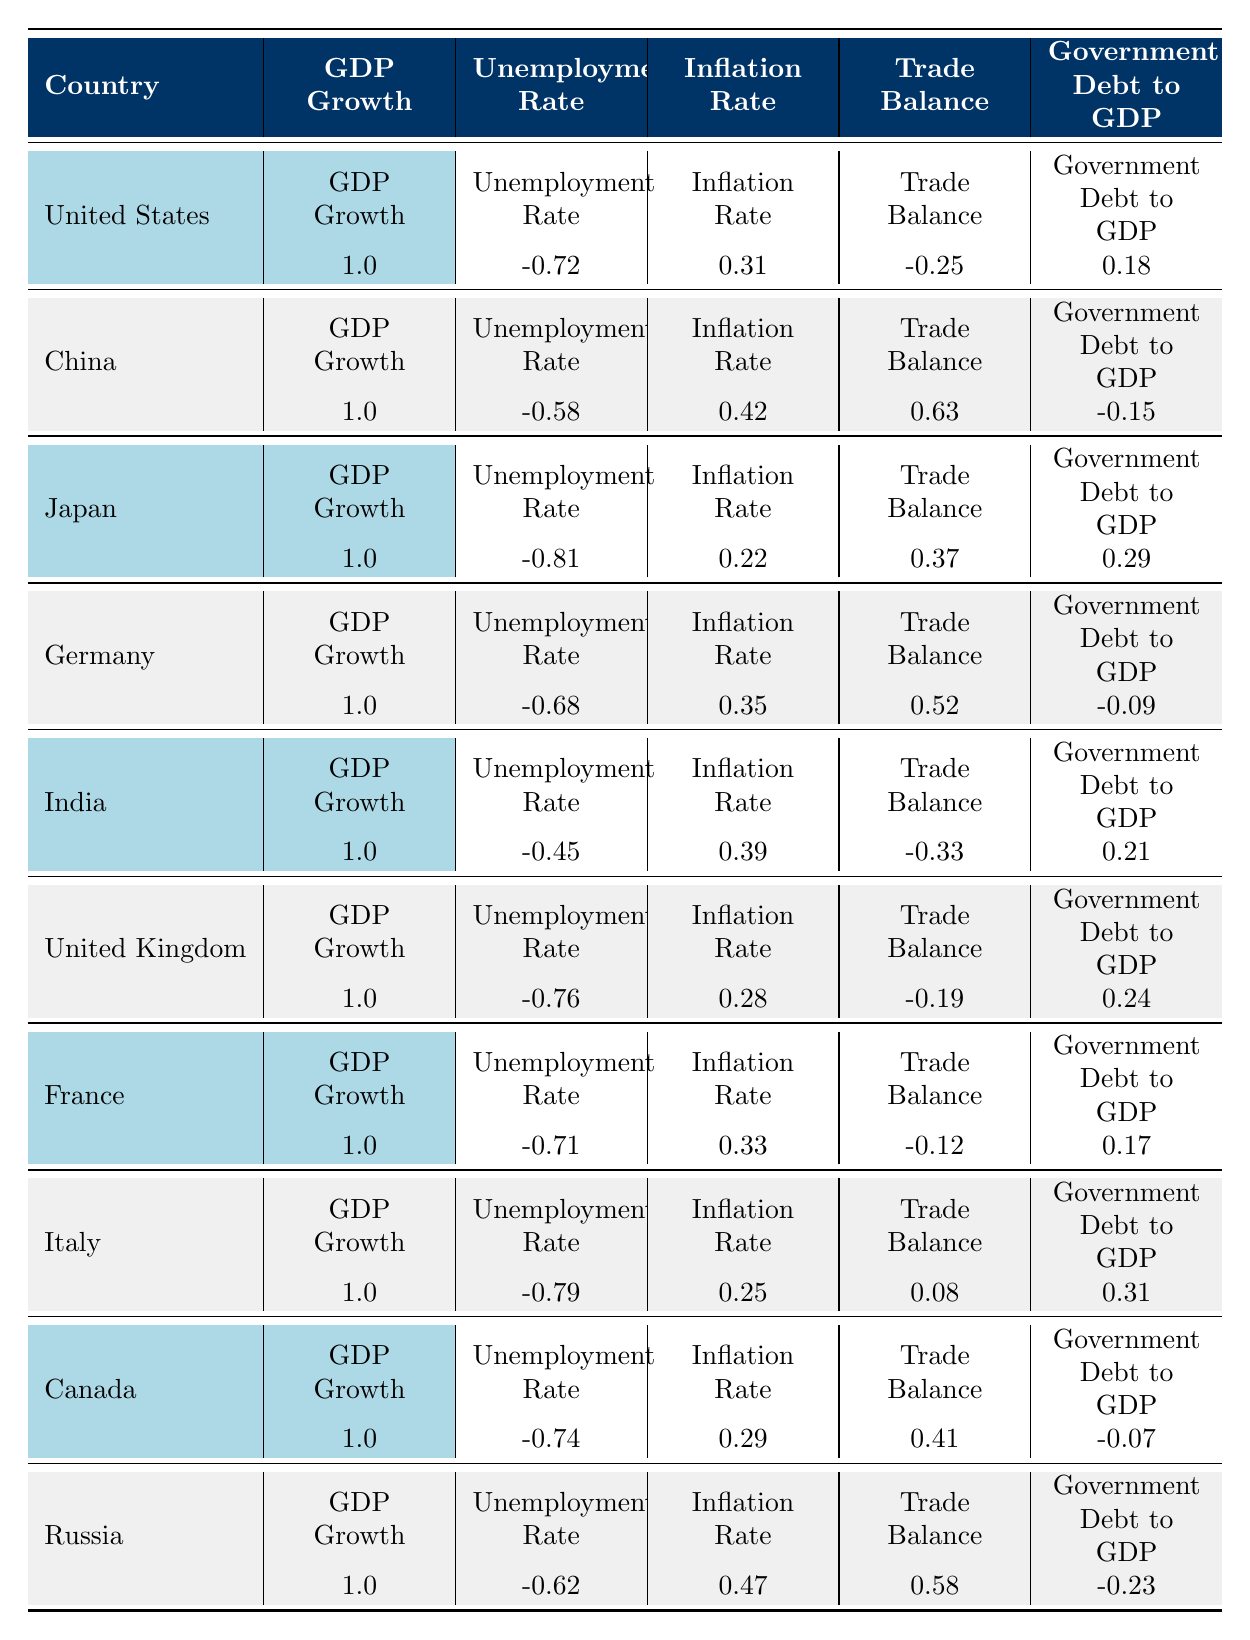What is the correlation of GDP growth with the unemployment rate for the United States? The correlation value for GDP growth and the unemployment rate for the United States is -0.72, as shown in the table under the relevant columns.
Answer: -0.72 Which country has the highest correlation between GDP growth and trade balance? Upon examining the trade balance correlations, China shows the highest correlation at 0.63 when compared to its GDP growth.
Answer: China Is the inflation rate positively correlated with GDP growth in India? The correlation value for GDP growth and inflation rate in India is 0.39, which indicates a positive correlation.
Answer: Yes What is the average correlation of GDP growth with inflation rates across the G20 countries listed? The correlations for inflation rates based on the table are: US (0.31), China (0.42), Japan (0.22), Germany (0.35), India (0.39), UK (0.28), France (0.33), Italy (0.25), Canada (0.29), and Russia (0.47). The sum is 0.31 + 0.42 + 0.22 + 0.35 + 0.39 + 0.28 + 0.33 + 0.25 + 0.29 + 0.47 = 3.27 and there are 10 data points, thus the average is 3.27 / 10 = 0.327.
Answer: 0.327 Does Japan have a higher correlation between GDP growth and government debt to GDP than Germany? Japan's correlation with government debt to GDP is 0.29, while Germany's is -0.09. Since 0.29 is greater than -0.09, the statement is true.
Answer: Yes Which country has the lowest correlation with government debt to GDP? Looking at the values, Germany has the lowest correlation with government debt to GDP at -0.09 when compared to all other countries in the table.
Answer: Germany What is the difference in the correlation of unemployment rate and GDP growth between the United Kingdom and Canada? The correlation of unemployment rate to GDP growth for the United Kingdom is -0.76 and for Canada, it is -0.74. The difference is calculated as -0.76 - (-0.74) = -0.02.
Answer: -0.02 Is there any country that shows a negative correlation between GDP growth and trade balance? Based on the table, Italy has a trade balance correlation of 0.08 with GDP growth, which is positive. However, US has -0.25 which indicates a negative correlation.
Answer: Yes What can be concluded about the relationship of GDP growth and unemployment rates for G20 countries? The correlations for unemployment rates with GDP growth are generally negative across the listed countries: ranging from -0.45 to -0.81, indicating that as GDP growth increases, unemployment tends to decrease for G20 countries.
Answer: Generally negative 